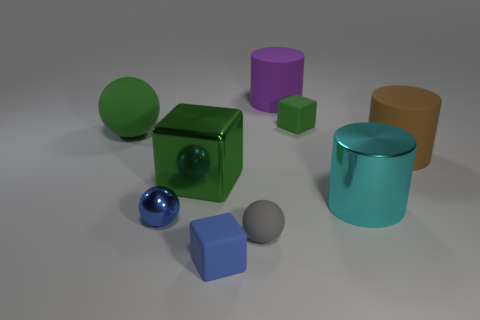How many blue blocks are the same size as the brown matte object?
Make the answer very short. 0. Is the material of the cube in front of the shiny cylinder the same as the green object behind the big green ball?
Keep it short and to the point. Yes. The large thing that is behind the block that is behind the brown matte cylinder is made of what material?
Your answer should be compact. Rubber. There is a small blue object that is behind the blue cube; what material is it?
Ensure brevity in your answer.  Metal. What number of gray metallic objects are the same shape as the tiny blue metallic thing?
Ensure brevity in your answer.  0. Do the large ball and the metal block have the same color?
Offer a terse response. Yes. There is a large green thing in front of the big green object that is on the left side of the small ball left of the small blue matte object; what is it made of?
Your answer should be very brief. Metal. Are there any tiny metallic objects in front of the green metal cube?
Ensure brevity in your answer.  Yes. What shape is the metal thing that is the same size as the gray rubber ball?
Ensure brevity in your answer.  Sphere. Is the material of the brown cylinder the same as the tiny green cube?
Ensure brevity in your answer.  Yes. 